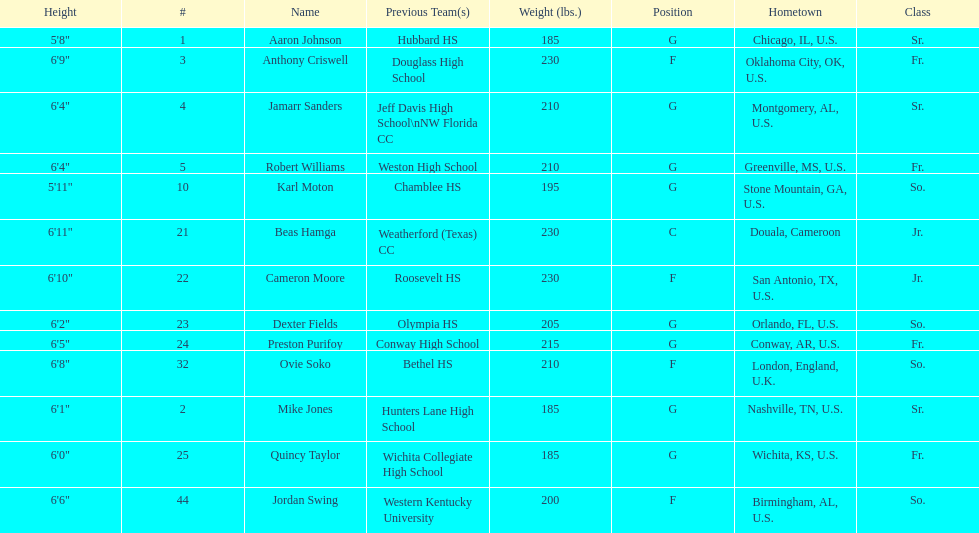Other than soko, tell me a player who is not from the us. Beas Hamga. 